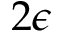<formula> <loc_0><loc_0><loc_500><loc_500>2 \epsilon</formula> 